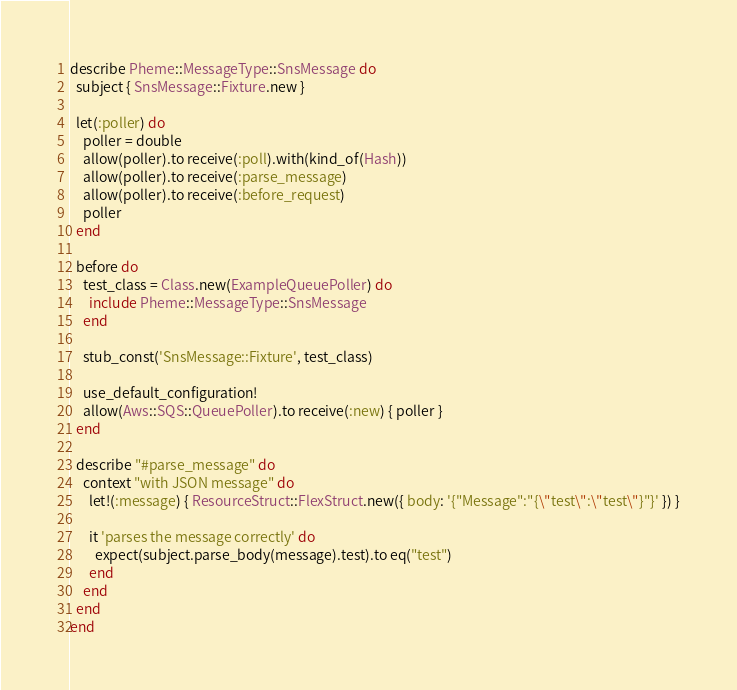<code> <loc_0><loc_0><loc_500><loc_500><_Ruby_>describe Pheme::MessageType::SnsMessage do
  subject { SnsMessage::Fixture.new }

  let(:poller) do
    poller = double
    allow(poller).to receive(:poll).with(kind_of(Hash))
    allow(poller).to receive(:parse_message)
    allow(poller).to receive(:before_request)
    poller
  end

  before do
    test_class = Class.new(ExampleQueuePoller) do
      include Pheme::MessageType::SnsMessage
    end

    stub_const('SnsMessage::Fixture', test_class)

    use_default_configuration!
    allow(Aws::SQS::QueuePoller).to receive(:new) { poller }
  end

  describe "#parse_message" do
    context "with JSON message" do
      let!(:message) { ResourceStruct::FlexStruct.new({ body: '{"Message":"{\"test\":\"test\"}"}' }) }

      it 'parses the message correctly' do
        expect(subject.parse_body(message).test).to eq("test")
      end
    end
  end
end
</code> 